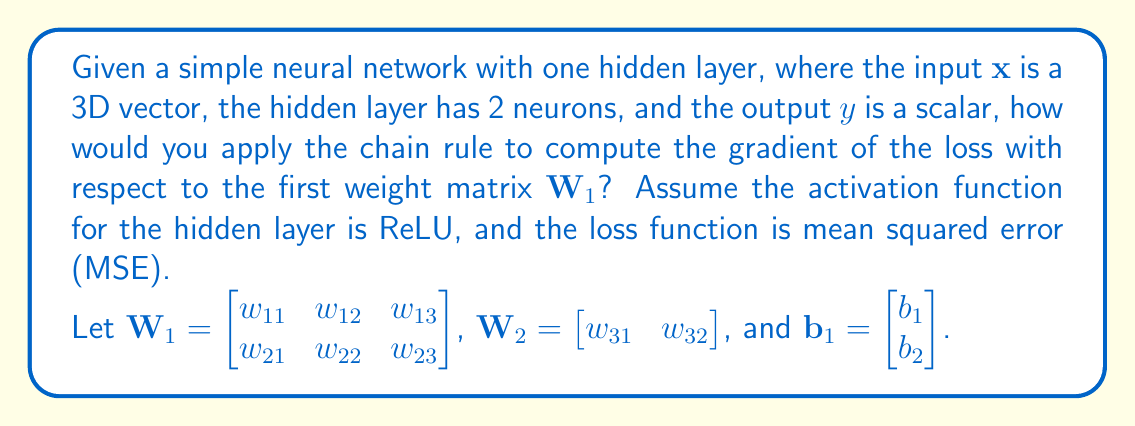Provide a solution to this math problem. To solve this problem, we'll apply the chain rule for tensor derivatives step by step:

1) First, let's define the forward pass of the neural network:
   $$\mathbf{h} = \text{ReLU}(\mathbf{W}_1\mathbf{x} + \mathbf{b}_1)$$
   $$y = \mathbf{W}_2\mathbf{h}$$

2) The loss function (MSE) is:
   $$L = \frac{1}{2}(y - y_{\text{true}})^2$$

3) To compute $\frac{\partial L}{\partial \mathbf{W}_1}$, we apply the chain rule:
   $$\frac{\partial L}{\partial \mathbf{W}_1} = \frac{\partial L}{\partial y} \cdot \frac{\partial y}{\partial \mathbf{h}} \cdot \frac{\partial \mathbf{h}}{\partial (\mathbf{W}_1\mathbf{x} + \mathbf{b}_1)} \cdot \frac{\partial (\mathbf{W}_1\mathbf{x} + \mathbf{b}_1)}{\partial \mathbf{W}_1}$$

4) Let's compute each term:
   a) $\frac{\partial L}{\partial y} = y - y_{\text{true}}$
   b) $\frac{\partial y}{\partial \mathbf{h}} = \mathbf{W}_2$
   c) $\frac{\partial \mathbf{h}}{\partial (\mathbf{W}_1\mathbf{x} + \mathbf{b}_1)} = \text{diag}(\mathbf{1}_{(\mathbf{W}_1\mathbf{x} + \mathbf{b}_1 > 0)})$ (element-wise derivative of ReLU)
   d) $\frac{\partial (\mathbf{W}_1\mathbf{x} + \mathbf{b}_1)}{\partial \mathbf{W}_1} = \mathbf{x}^T$

5) Putting it all together:
   $$\frac{\partial L}{\partial \mathbf{W}_1} = (y - y_{\text{true}}) \cdot \mathbf{W}_2 \cdot \text{diag}(\mathbf{1}_{(\mathbf{W}_1\mathbf{x} + \mathbf{b}_1 > 0)}) \cdot \mathbf{x}^T$$

6) In JavaScript-like notation, this would be similar to:
   ```javascript
   const dL_dW1 = (y - y_true) * W2 * (W1.dot(x).add(b1).map(v => v > 0 ? 1 : 0)) * x.transpose();
   ```

   Where `dot` is matrix multiplication, `add` is element-wise addition, `map` applies a function element-wise, and `transpose` is matrix transposition.
Answer: $\frac{\partial L}{\partial \mathbf{W}_1} = (y - y_{\text{true}}) \cdot \mathbf{W}_2 \cdot \text{diag}(\mathbf{1}_{(\mathbf{W}_1\mathbf{x} + \mathbf{b}_1 > 0)}) \cdot \mathbf{x}^T$ 